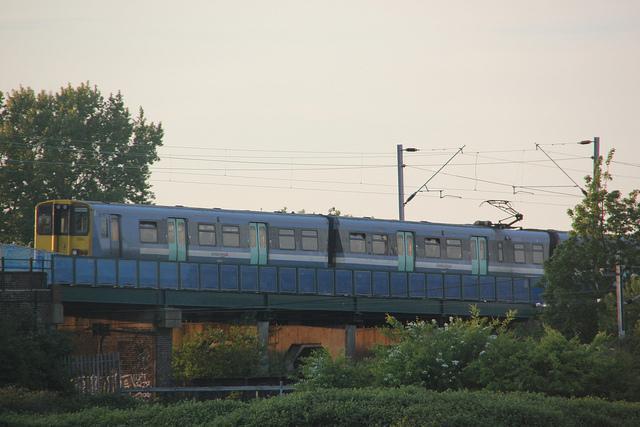How many boxcars are visible?
Give a very brief answer. 2. How many teddy bears is the girl holding?
Give a very brief answer. 0. 